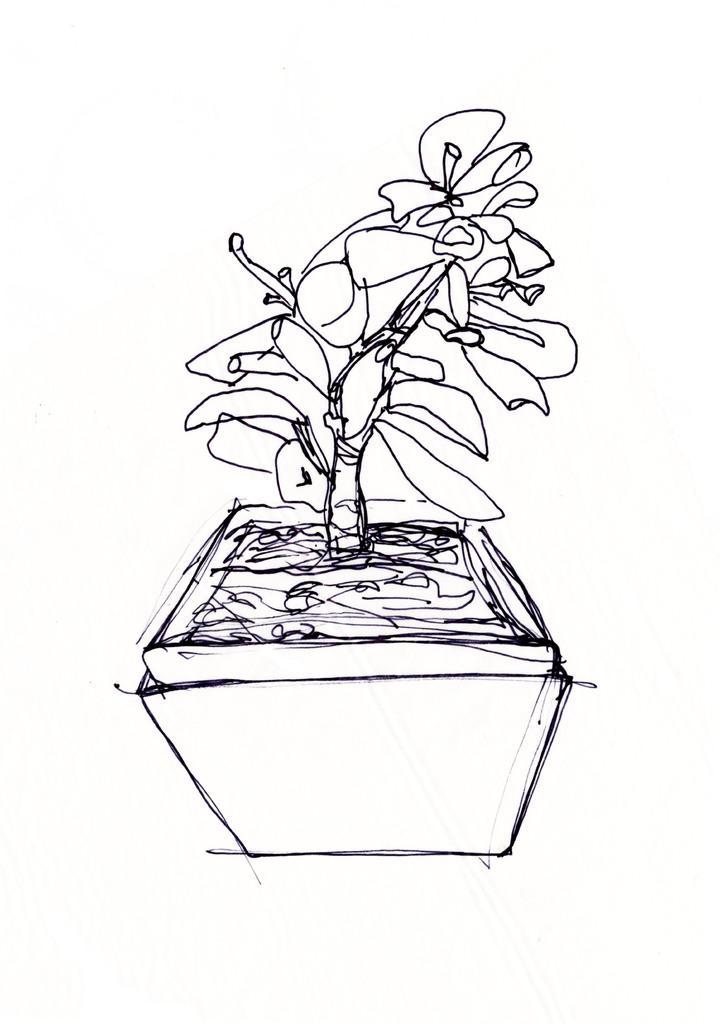Could you give a brief overview of what you see in this image? In this image I can see the art of the flower pot and there is a white background. 